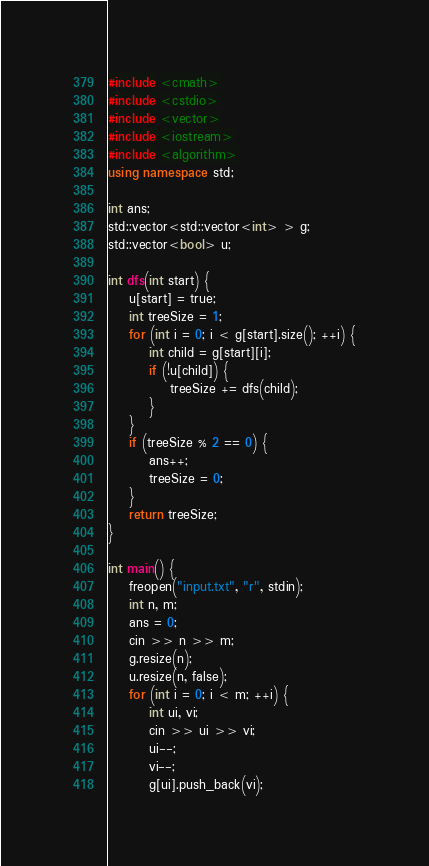Convert code to text. <code><loc_0><loc_0><loc_500><loc_500><_C++_>#include <cmath>
#include <cstdio>
#include <vector>
#include <iostream>
#include <algorithm>
using namespace std;

int ans;
std::vector<std::vector<int> > g;
std::vector<bool> u;

int dfs(int start) {
    u[start] = true;
    int treeSize = 1;
    for (int i = 0; i < g[start].size(); ++i) {
        int child = g[start][i];
        if (!u[child]) {
            treeSize += dfs(child);
        }
    }
    if (treeSize % 2 == 0) {
        ans++;
        treeSize = 0;
    }
    return treeSize;
}

int main() {
    freopen("input.txt", "r", stdin);
    int n, m;
    ans = 0;
    cin >> n >> m;
    g.resize(n);
    u.resize(n, false);
    for (int i = 0; i < m; ++i) {
        int ui, vi;
        cin >> ui >> vi;
        ui--;
        vi--;
        g[ui].push_back(vi);</code> 